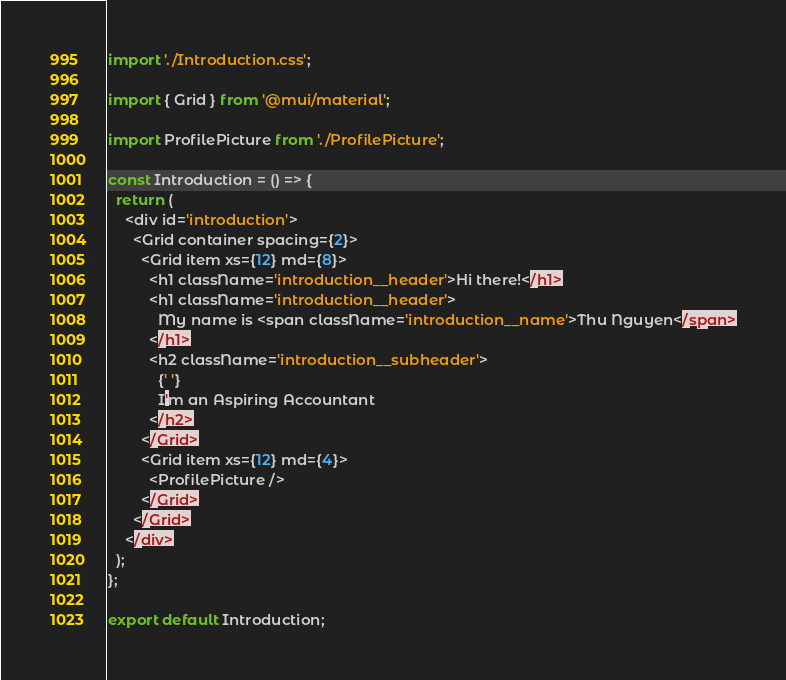Convert code to text. <code><loc_0><loc_0><loc_500><loc_500><_JavaScript_>import './Introduction.css';

import { Grid } from '@mui/material';

import ProfilePicture from './ProfilePicture';

const Introduction = () => {
  return (
    <div id='introduction'>
      <Grid container spacing={2}>
        <Grid item xs={12} md={8}>
          <h1 className='introduction__header'>Hi there!</h1>
          <h1 className='introduction__header'>
            My name is <span className='introduction__name'>Thu Nguyen</span>
          </h1>
          <h2 className='introduction__subheader'>
            {' '}
            I'm an Aspiring Accountant
          </h2>
        </Grid>
        <Grid item xs={12} md={4}>
          <ProfilePicture />
        </Grid>
      </Grid>
    </div>
  );
};

export default Introduction;
</code> 